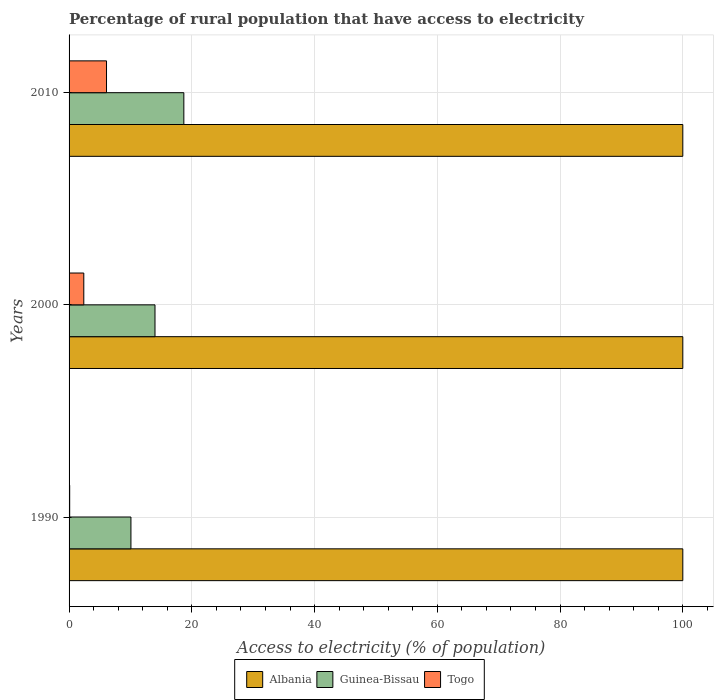How many different coloured bars are there?
Your answer should be very brief. 3. How many bars are there on the 1st tick from the top?
Your answer should be very brief. 3. In how many cases, is the number of bars for a given year not equal to the number of legend labels?
Give a very brief answer. 0. What is the percentage of rural population that have access to electricity in Guinea-Bissau in 2000?
Offer a terse response. 14. Across all years, what is the maximum percentage of rural population that have access to electricity in Togo?
Provide a short and direct response. 6.1. Across all years, what is the minimum percentage of rural population that have access to electricity in Albania?
Provide a short and direct response. 100. In which year was the percentage of rural population that have access to electricity in Togo minimum?
Offer a very short reply. 1990. What is the total percentage of rural population that have access to electricity in Albania in the graph?
Provide a succinct answer. 300. What is the difference between the percentage of rural population that have access to electricity in Guinea-Bissau in 1990 and that in 2000?
Keep it short and to the point. -3.92. What is the difference between the percentage of rural population that have access to electricity in Togo in 1990 and the percentage of rural population that have access to electricity in Guinea-Bissau in 2010?
Your response must be concise. -18.6. What is the average percentage of rural population that have access to electricity in Togo per year?
Ensure brevity in your answer.  2.87. In the year 1990, what is the difference between the percentage of rural population that have access to electricity in Guinea-Bissau and percentage of rural population that have access to electricity in Togo?
Offer a very short reply. 9.98. In how many years, is the percentage of rural population that have access to electricity in Albania greater than 40 %?
Your answer should be compact. 3. What is the ratio of the percentage of rural population that have access to electricity in Togo in 1990 to that in 2010?
Give a very brief answer. 0.02. Is the difference between the percentage of rural population that have access to electricity in Guinea-Bissau in 2000 and 2010 greater than the difference between the percentage of rural population that have access to electricity in Togo in 2000 and 2010?
Your answer should be very brief. No. What is the difference between the highest and the lowest percentage of rural population that have access to electricity in Togo?
Ensure brevity in your answer.  6. In how many years, is the percentage of rural population that have access to electricity in Guinea-Bissau greater than the average percentage of rural population that have access to electricity in Guinea-Bissau taken over all years?
Give a very brief answer. 1. What does the 1st bar from the top in 2000 represents?
Your answer should be compact. Togo. What does the 3rd bar from the bottom in 2010 represents?
Give a very brief answer. Togo. Is it the case that in every year, the sum of the percentage of rural population that have access to electricity in Guinea-Bissau and percentage of rural population that have access to electricity in Togo is greater than the percentage of rural population that have access to electricity in Albania?
Ensure brevity in your answer.  No. Does the graph contain any zero values?
Ensure brevity in your answer.  No. Does the graph contain grids?
Provide a short and direct response. Yes. Where does the legend appear in the graph?
Give a very brief answer. Bottom center. How many legend labels are there?
Your answer should be very brief. 3. What is the title of the graph?
Provide a short and direct response. Percentage of rural population that have access to electricity. What is the label or title of the X-axis?
Offer a very short reply. Access to electricity (% of population). What is the Access to electricity (% of population) of Albania in 1990?
Give a very brief answer. 100. What is the Access to electricity (% of population) in Guinea-Bissau in 1990?
Provide a short and direct response. 10.08. What is the Access to electricity (% of population) of Albania in 2000?
Keep it short and to the point. 100. What is the Access to electricity (% of population) of Togo in 2010?
Offer a very short reply. 6.1. Across all years, what is the maximum Access to electricity (% of population) of Togo?
Give a very brief answer. 6.1. Across all years, what is the minimum Access to electricity (% of population) of Guinea-Bissau?
Ensure brevity in your answer.  10.08. What is the total Access to electricity (% of population) of Albania in the graph?
Give a very brief answer. 300. What is the total Access to electricity (% of population) in Guinea-Bissau in the graph?
Your response must be concise. 42.78. What is the total Access to electricity (% of population) in Togo in the graph?
Offer a very short reply. 8.6. What is the difference between the Access to electricity (% of population) of Guinea-Bissau in 1990 and that in 2000?
Provide a succinct answer. -3.92. What is the difference between the Access to electricity (% of population) of Albania in 1990 and that in 2010?
Your response must be concise. 0. What is the difference between the Access to electricity (% of population) of Guinea-Bissau in 1990 and that in 2010?
Keep it short and to the point. -8.62. What is the difference between the Access to electricity (% of population) of Togo in 1990 and that in 2010?
Provide a succinct answer. -6. What is the difference between the Access to electricity (% of population) of Albania in 2000 and that in 2010?
Ensure brevity in your answer.  0. What is the difference between the Access to electricity (% of population) of Albania in 1990 and the Access to electricity (% of population) of Guinea-Bissau in 2000?
Ensure brevity in your answer.  86. What is the difference between the Access to electricity (% of population) in Albania in 1990 and the Access to electricity (% of population) in Togo in 2000?
Keep it short and to the point. 97.6. What is the difference between the Access to electricity (% of population) in Guinea-Bissau in 1990 and the Access to electricity (% of population) in Togo in 2000?
Give a very brief answer. 7.68. What is the difference between the Access to electricity (% of population) of Albania in 1990 and the Access to electricity (% of population) of Guinea-Bissau in 2010?
Provide a short and direct response. 81.3. What is the difference between the Access to electricity (% of population) in Albania in 1990 and the Access to electricity (% of population) in Togo in 2010?
Provide a succinct answer. 93.9. What is the difference between the Access to electricity (% of population) in Guinea-Bissau in 1990 and the Access to electricity (% of population) in Togo in 2010?
Keep it short and to the point. 3.98. What is the difference between the Access to electricity (% of population) in Albania in 2000 and the Access to electricity (% of population) in Guinea-Bissau in 2010?
Make the answer very short. 81.3. What is the difference between the Access to electricity (% of population) of Albania in 2000 and the Access to electricity (% of population) of Togo in 2010?
Your answer should be compact. 93.9. What is the average Access to electricity (% of population) of Guinea-Bissau per year?
Make the answer very short. 14.26. What is the average Access to electricity (% of population) of Togo per year?
Offer a very short reply. 2.87. In the year 1990, what is the difference between the Access to electricity (% of population) in Albania and Access to electricity (% of population) in Guinea-Bissau?
Ensure brevity in your answer.  89.92. In the year 1990, what is the difference between the Access to electricity (% of population) of Albania and Access to electricity (% of population) of Togo?
Ensure brevity in your answer.  99.9. In the year 1990, what is the difference between the Access to electricity (% of population) in Guinea-Bissau and Access to electricity (% of population) in Togo?
Offer a terse response. 9.98. In the year 2000, what is the difference between the Access to electricity (% of population) in Albania and Access to electricity (% of population) in Togo?
Offer a terse response. 97.6. In the year 2010, what is the difference between the Access to electricity (% of population) in Albania and Access to electricity (% of population) in Guinea-Bissau?
Provide a succinct answer. 81.3. In the year 2010, what is the difference between the Access to electricity (% of population) in Albania and Access to electricity (% of population) in Togo?
Offer a terse response. 93.9. What is the ratio of the Access to electricity (% of population) in Guinea-Bissau in 1990 to that in 2000?
Provide a succinct answer. 0.72. What is the ratio of the Access to electricity (% of population) in Togo in 1990 to that in 2000?
Make the answer very short. 0.04. What is the ratio of the Access to electricity (% of population) of Guinea-Bissau in 1990 to that in 2010?
Ensure brevity in your answer.  0.54. What is the ratio of the Access to electricity (% of population) of Togo in 1990 to that in 2010?
Keep it short and to the point. 0.02. What is the ratio of the Access to electricity (% of population) of Guinea-Bissau in 2000 to that in 2010?
Offer a very short reply. 0.75. What is the ratio of the Access to electricity (% of population) of Togo in 2000 to that in 2010?
Your answer should be compact. 0.39. What is the difference between the highest and the second highest Access to electricity (% of population) in Togo?
Give a very brief answer. 3.7. What is the difference between the highest and the lowest Access to electricity (% of population) in Guinea-Bissau?
Your answer should be compact. 8.62. 